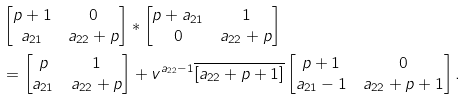<formula> <loc_0><loc_0><loc_500><loc_500>& \begin{bmatrix} p + 1 & 0 \\ a _ { 2 1 } & a _ { 2 2 } + p \end{bmatrix} * \begin{bmatrix} p + a _ { 2 1 } & 1 \\ 0 & a _ { 2 2 } + p \end{bmatrix} \\ & = \begin{bmatrix} p & 1 \\ a _ { 2 1 } & a _ { 2 2 } + p \end{bmatrix} + v ^ { a _ { 2 2 } - 1 } \overline { [ a _ { 2 2 } + p + 1 ] } \begin{bmatrix} p + 1 & 0 \\ a _ { 2 1 } - 1 & a _ { 2 2 } + p + 1 \end{bmatrix} .</formula> 